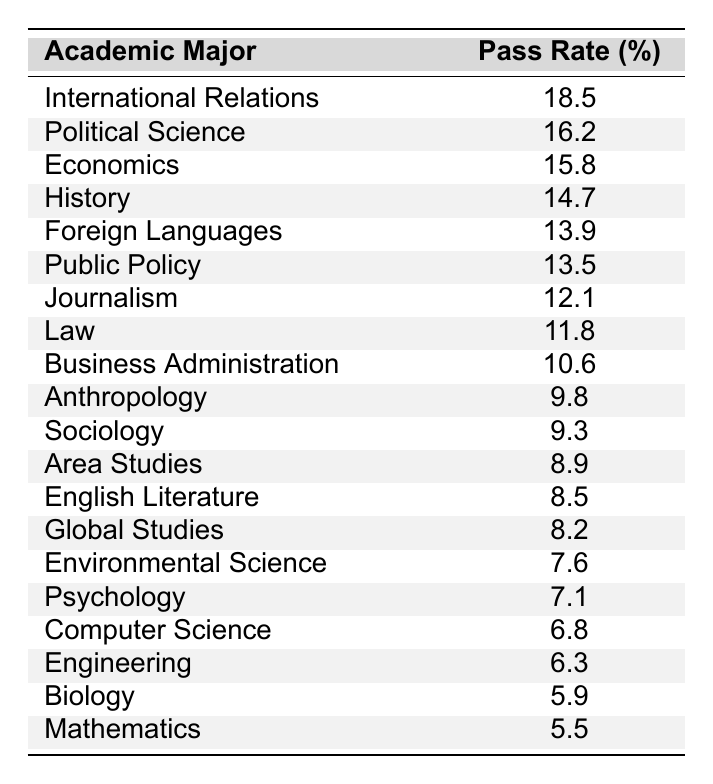What is the pass rate for International Relations majors? The table shows that the pass rate for International Relations is listed directly under the corresponding major, which is 18.5%.
Answer: 18.5% Which major has the lowest pass rate? By scanning the table, the pass rate for Mathematics is the lowest at 5.5%.
Answer: Mathematics What is the difference in pass rates between Political Science and Law? The pass rate for Political Science is 16.2%, while Law's pass rate is 11.8%. The difference is 16.2% - 11.8% = 4.4%.
Answer: 4.4% What is the average pass rate for the top three majors? The top three majors by pass rate are International Relations (18.5%), Political Science (16.2%), and Economics (15.8%). To find the average, add these and divide by 3: (18.5 + 16.2 + 15.8) / 3 = 16.5%.
Answer: 16.5% Is the pass rate for Foreign Languages higher than that for Public Policy? The pass rate for Foreign Languages is 13.9%, while Public Policy's is 13.5%. Since 13.9% is greater than 13.5%, the statement is true.
Answer: Yes What is the total pass rate for majors ranked 10th to 15th? The majors ranked 10th to 15th are Anthropology (9.8%), Sociology (9.3%), Area Studies (8.9%), English Literature (8.5%), and Global Studies (8.2%). Adding these gives: 9.8 + 9.3 + 8.9 + 8.5 + 8.2 = 44.7%.
Answer: 44.7% Which major has a higher pass rate: Business Administration or Psychology? Business Administration has a pass rate of 10.6% and Psychology has 7.1%. Since 10.6% is greater than 7.1%, Business Administration has a higher pass rate.
Answer: Business Administration If an Economics major succeeds, what would be the success rank among the listed majors? Economics has a pass rate of 15.8%, which ranks it third in the list behind International Relations and Political Science.
Answer: Third What is the range of pass rates for all the majors listed? The highest pass rate is 18.5% (International Relations) and the lowest is 5.5% (Mathematics). The range is calculated as 18.5% - 5.5% = 13%.
Answer: 13% How many majors have a pass rate below 10%? The table lists the following majors below 10%: Anthropology (9.8%), Sociology (9.3%), Area Studies (8.9%), English Literature (8.5%), Global Studies (8.2%), Environmental Science (7.6%), Psychology (7.1%), Computer Science (6.8%), Engineering (6.3%), Biology (5.9%), and Mathematics (5.5%). This totals 11 majors below 10%.
Answer: 11 What is the overall trend in pass rates as academic majors move down the ranking? Upon observing the table, pass rates generally decrease as one moves down the list of majors, indicating a trend of decreasing success rates.
Answer: Decreasing trend 